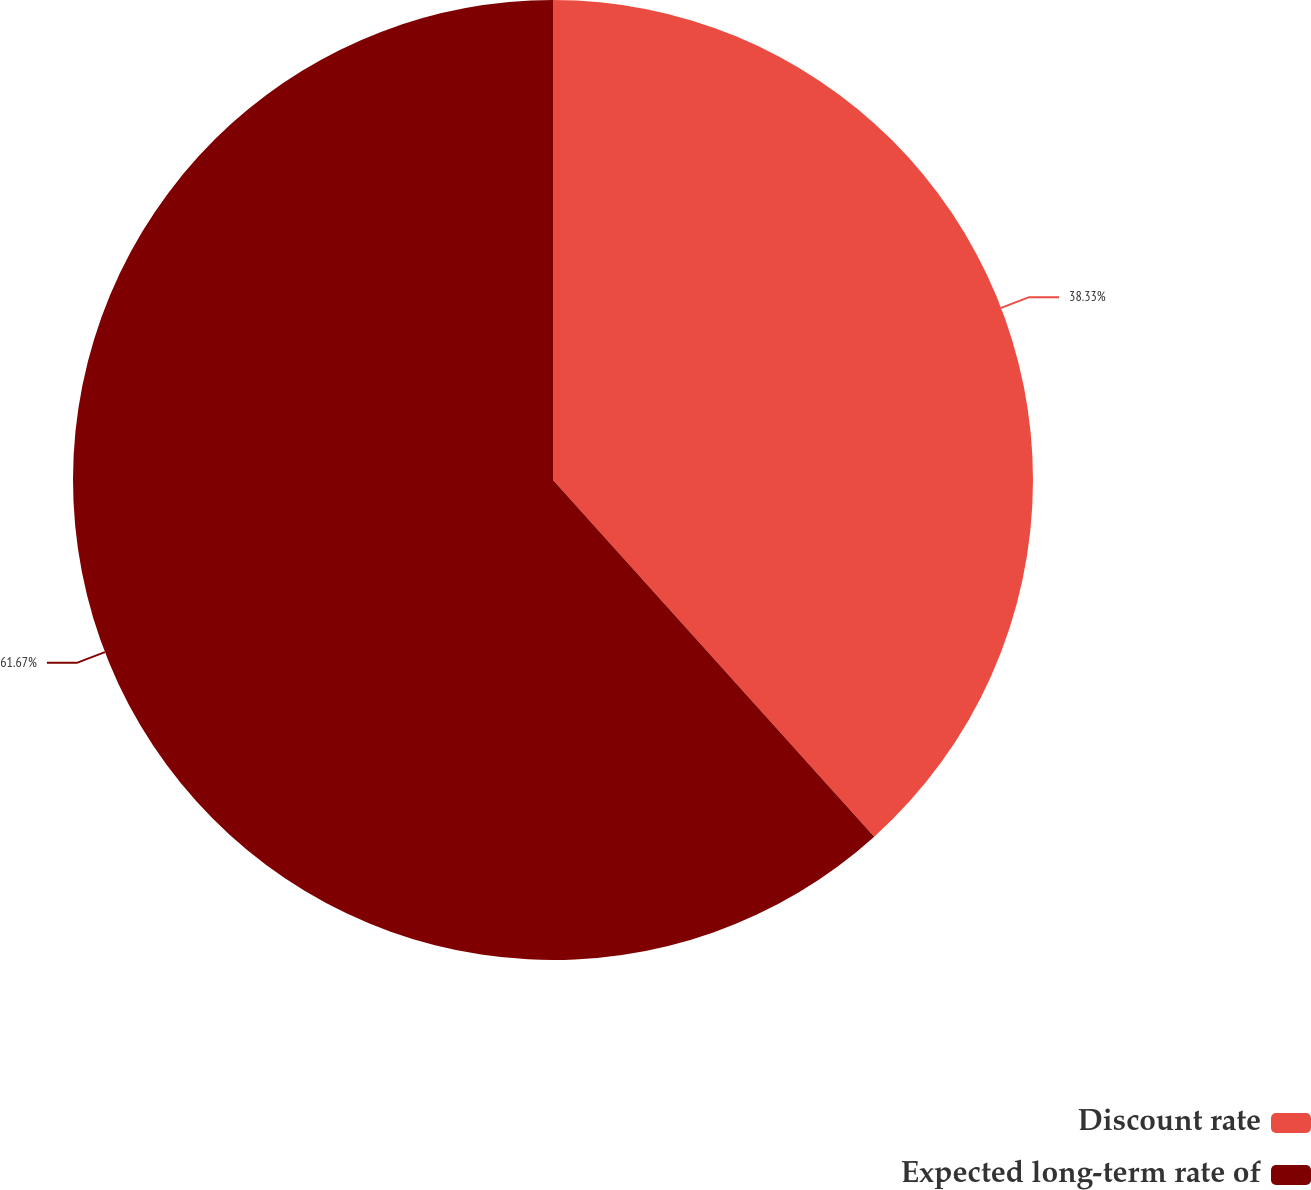<chart> <loc_0><loc_0><loc_500><loc_500><pie_chart><fcel>Discount rate<fcel>Expected long-term rate of<nl><fcel>38.33%<fcel>61.67%<nl></chart> 